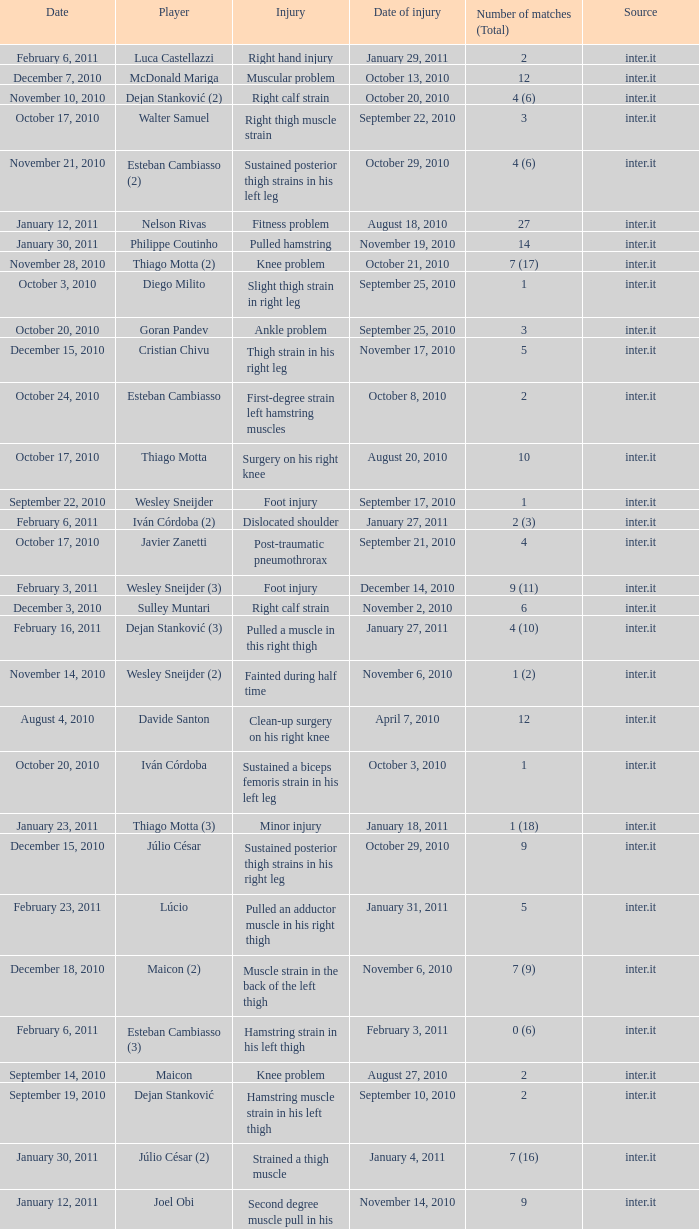What is the date of injury when the injury is sustained posterior thigh strains in his left leg? October 29, 2010. Parse the full table. {'header': ['Date', 'Player', 'Injury', 'Date of injury', 'Number of matches (Total)', 'Source'], 'rows': [['February 6, 2011', 'Luca Castellazzi', 'Right hand injury', 'January 29, 2011', '2', 'inter.it'], ['December 7, 2010', 'McDonald Mariga', 'Muscular problem', 'October 13, 2010', '12', 'inter.it'], ['November 10, 2010', 'Dejan Stanković (2)', 'Right calf strain', 'October 20, 2010', '4 (6)', 'inter.it'], ['October 17, 2010', 'Walter Samuel', 'Right thigh muscle strain', 'September 22, 2010', '3', 'inter.it'], ['November 21, 2010', 'Esteban Cambiasso (2)', 'Sustained posterior thigh strains in his left leg', 'October 29, 2010', '4 (6)', 'inter.it'], ['January 12, 2011', 'Nelson Rivas', 'Fitness problem', 'August 18, 2010', '27', 'inter.it'], ['January 30, 2011', 'Philippe Coutinho', 'Pulled hamstring', 'November 19, 2010', '14', 'inter.it'], ['November 28, 2010', 'Thiago Motta (2)', 'Knee problem', 'October 21, 2010', '7 (17)', 'inter.it'], ['October 3, 2010', 'Diego Milito', 'Slight thigh strain in right leg', 'September 25, 2010', '1', 'inter.it'], ['October 20, 2010', 'Goran Pandev', 'Ankle problem', 'September 25, 2010', '3', 'inter.it'], ['December 15, 2010', 'Cristian Chivu', 'Thigh strain in his right leg', 'November 17, 2010', '5', 'inter.it'], ['October 24, 2010', 'Esteban Cambiasso', 'First-degree strain left hamstring muscles', 'October 8, 2010', '2', 'inter.it'], ['October 17, 2010', 'Thiago Motta', 'Surgery on his right knee', 'August 20, 2010', '10', 'inter.it'], ['September 22, 2010', 'Wesley Sneijder', 'Foot injury', 'September 17, 2010', '1', 'inter.it'], ['February 6, 2011', 'Iván Córdoba (2)', 'Dislocated shoulder', 'January 27, 2011', '2 (3)', 'inter.it'], ['October 17, 2010', 'Javier Zanetti', 'Post-traumatic pneumothrorax', 'September 21, 2010', '4', 'inter.it'], ['February 3, 2011', 'Wesley Sneijder (3)', 'Foot injury', 'December 14, 2010', '9 (11)', 'inter.it'], ['December 3, 2010', 'Sulley Muntari', 'Right calf strain', 'November 2, 2010', '6', 'inter.it'], ['February 16, 2011', 'Dejan Stanković (3)', 'Pulled a muscle in this right thigh', 'January 27, 2011', '4 (10)', 'inter.it'], ['November 14, 2010', 'Wesley Sneijder (2)', 'Fainted during half time', 'November 6, 2010', '1 (2)', 'inter.it'], ['August 4, 2010', 'Davide Santon', 'Clean-up surgery on his right knee', 'April 7, 2010', '12', 'inter.it'], ['October 20, 2010', 'Iván Córdoba', 'Sustained a biceps femoris strain in his left leg', 'October 3, 2010', '1', 'inter.it'], ['January 23, 2011', 'Thiago Motta (3)', 'Minor injury', 'January 18, 2011', '1 (18)', 'inter.it'], ['December 15, 2010', 'Júlio César', 'Sustained posterior thigh strains in his right leg', 'October 29, 2010', '9', 'inter.it'], ['February 23, 2011', 'Lúcio', 'Pulled an adductor muscle in his right thigh', 'January 31, 2011', '5', 'inter.it'], ['December 18, 2010', 'Maicon (2)', 'Muscle strain in the back of the left thigh', 'November 6, 2010', '7 (9)', 'inter.it'], ['February 6, 2011', 'Esteban Cambiasso (3)', 'Hamstring strain in his left thigh', 'February 3, 2011', '0 (6)', 'inter.it'], ['September 14, 2010', 'Maicon', 'Knee problem', 'August 27, 2010', '2', 'inter.it'], ['September 19, 2010', 'Dejan Stanković', 'Hamstring muscle strain in his left thigh', 'September 10, 2010', '2', 'inter.it'], ['January 30, 2011', 'Júlio César (2)', 'Strained a thigh muscle', 'January 4, 2011', '7 (16)', 'inter.it'], ['January 12, 2011', 'Joel Obi', 'Second degree muscle pull in his left hamstring', 'November 14, 2010', '9', 'inter.it']]} 